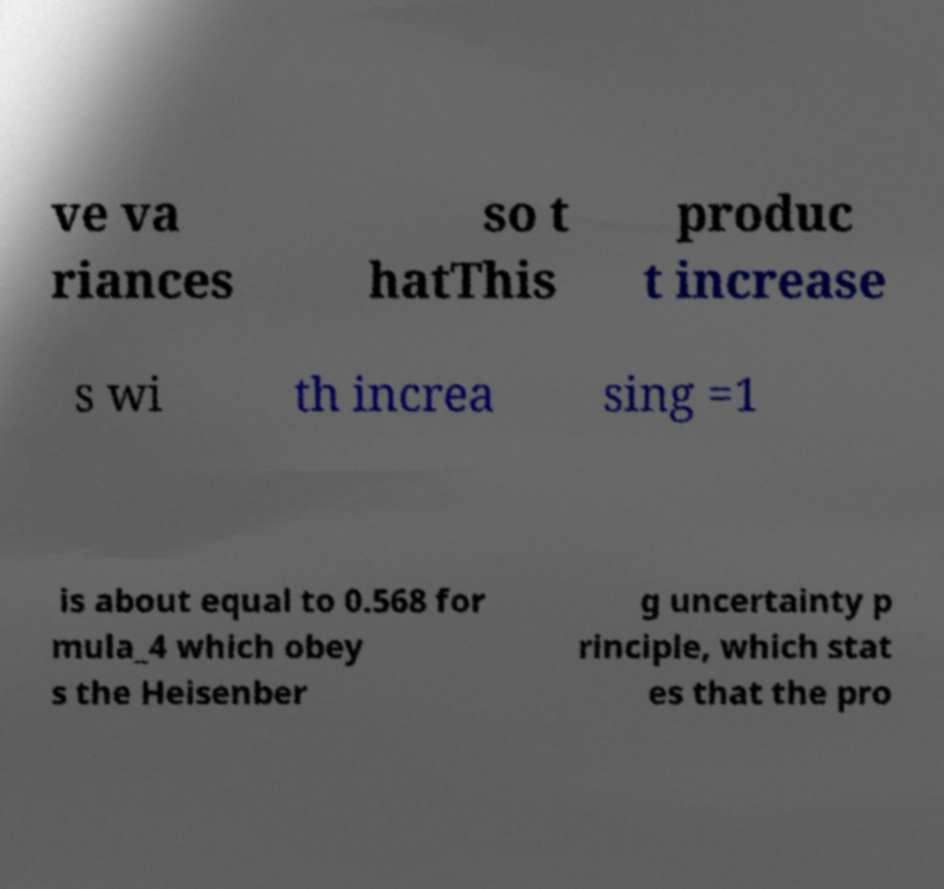Could you extract and type out the text from this image? ve va riances so t hatThis produc t increase s wi th increa sing =1 is about equal to 0.568 for mula_4 which obey s the Heisenber g uncertainty p rinciple, which stat es that the pro 